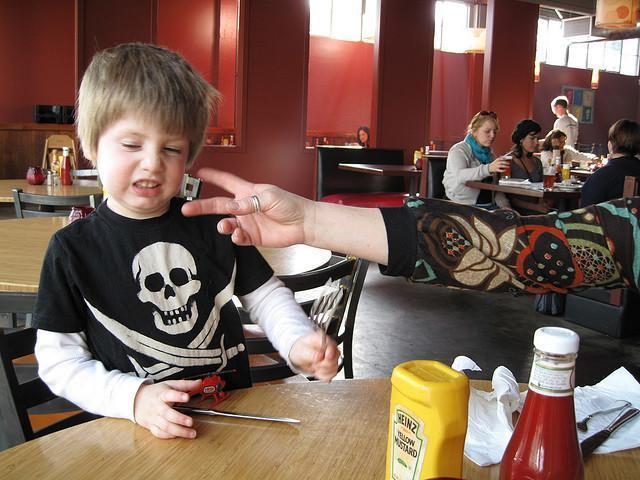Where is the table the boy is sitting at?
Choose the right answer and clarify with the format: 'Answer: answer
Rationale: rationale.'
Options: Police station, library, post office, restaurant. Answer: restaurant.
Rationale: There are many patrons seen at tables in the background, indicating this is not someone's home but is a kitchen. 